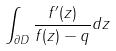<formula> <loc_0><loc_0><loc_500><loc_500>\int _ { \partial D } \frac { f ^ { \prime } ( z ) } { f ( z ) - q } d z</formula> 